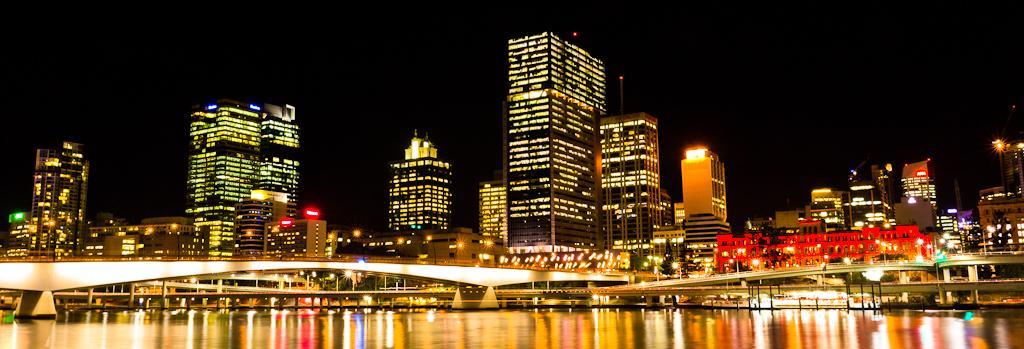How would you summarize this image in a sentence or two? In the foreground we can see the water. Here we can see the bridges. In the background, we can see the tower buildings. Here we can see a dark sky. 